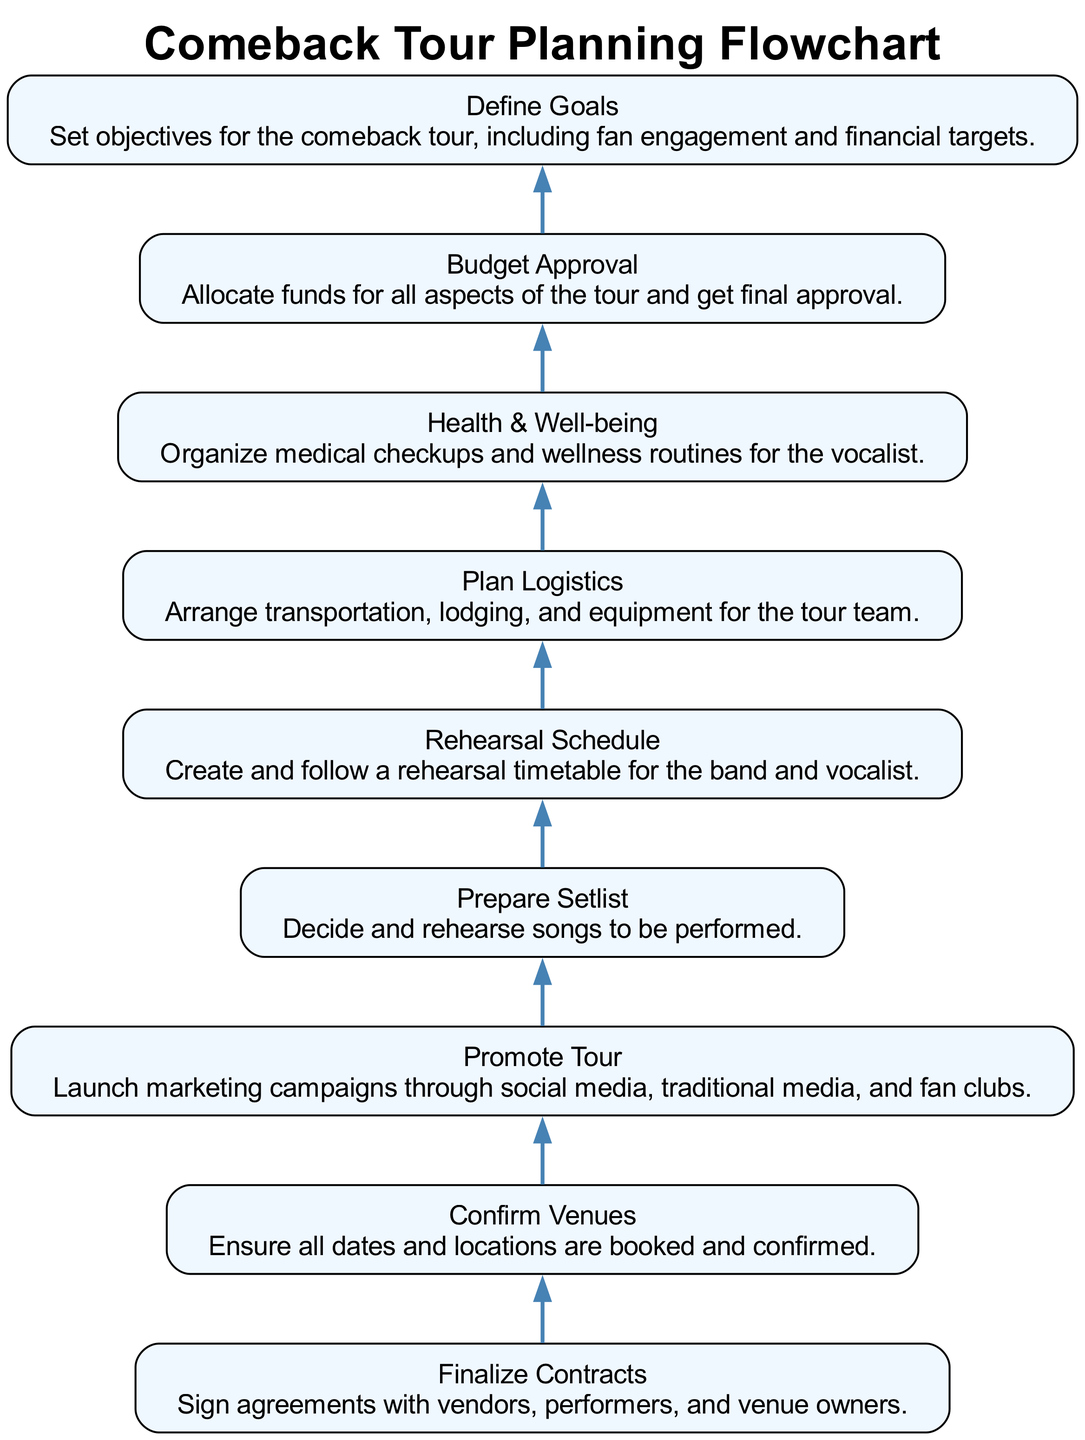What is the final step before Finalize Contracts? According to the flowchart, "Budget Approval" is the step preceding "Finalize Contracts". Therefore, we look at the node directly above "Finalize Contracts", which is "Budget Approval".
Answer: Budget Approval How many nodes are there in total? By counting each unique step listed in the flowchart, there are nine nodes representing different stages in the planning process, from defining goals to finalizing contracts.
Answer: Nine What is the third step in the sequence? Tracing the flow from the bottom of the diagram, the sequence starts with "Define Goals," "Budget Approval," "Health & Well-being," and then the next step is "Plan Logistics." Thus, the third step is "Promote Tour."
Answer: Promote Tour Which step directly follows Confirm Venues? Looking at the flowchart, "Finalize Contracts" follows "Confirm Venues" as the next stage in the process after confirming all bookings and dates for the tour.
Answer: Finalize Contracts What are the two steps that precede Prepare Setlist? To identify the steps preceding "Prepare Setlist," we see that the immediate previous steps are "Rehearsal Schedule" and "Promote Tour." Both of these contribute to preparing the setlist effectively by ensuring the performance is well-rehearsed and promoted.
Answer: Rehearsal Schedule, Promote Tour What is the primary goal outlined in Define Goals? The main objective in the "Define Goals" step focuses on setting targets for fan engagement and financial outcomes, making it a crucial part of the planning process.
Answer: Fan engagement and financial targets What is the relationship between Health & Well-being and Budget Approval? "Health & Well-being" is dependent on "Budget Approval" since a budget must be allocated for medical checkups and wellness routines, making it critical in approving the overall tour budget. The flowchart shows that Health & Well-being happens after Budget Approval.
Answer: Dependency What is the purpose of the Promote Tour step? The "Promote Tour" step is designed to launch marketing campaigns through various channels to increase visibility and engage fans, thus promoting the comeback effectively.
Answer: Launch marketing campaigns What step follows Preparing Setlist? The flowchart indicates that after "Prepare Setlist," the next step in the process is "Rehearsal Schedule," which is critical for ensuring that the songs are ready for performance.
Answer: Rehearsal Schedule 